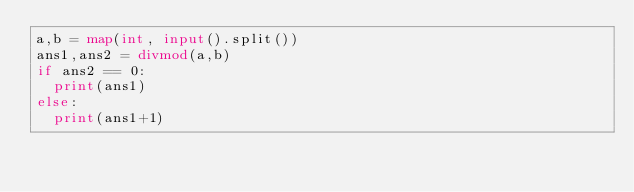<code> <loc_0><loc_0><loc_500><loc_500><_Python_>a,b = map(int, input().split())
ans1,ans2 = divmod(a,b)
if ans2 == 0:
  print(ans1)
else:
  print(ans1+1)</code> 